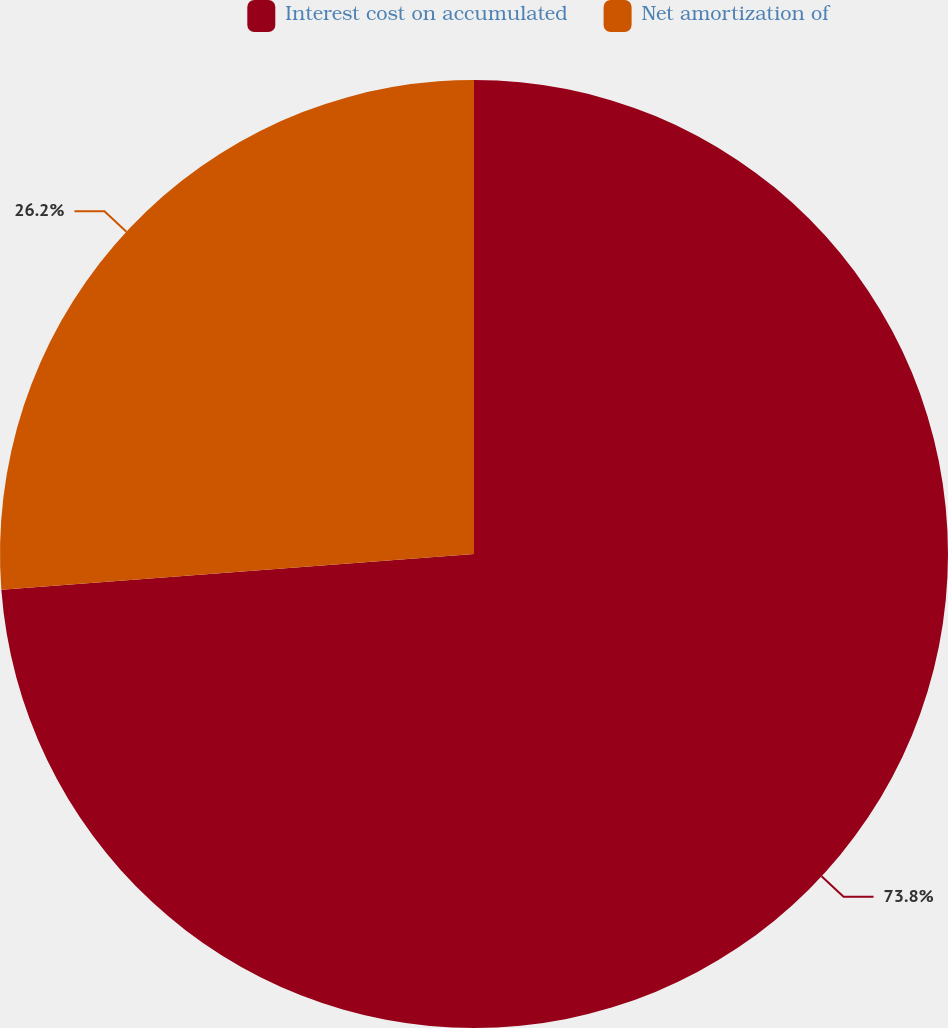<chart> <loc_0><loc_0><loc_500><loc_500><pie_chart><fcel>Interest cost on accumulated<fcel>Net amortization of<nl><fcel>73.8%<fcel>26.2%<nl></chart> 